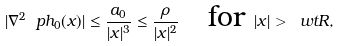<formula> <loc_0><loc_0><loc_500><loc_500>| \nabla ^ { 2 } \ p h _ { 0 } ( x ) | \leq \frac { a _ { 0 } } { | x | ^ { 3 } } \leq \frac { \rho } { | x | ^ { 2 } } \quad \text {for } | x | > { \ w t R } ,</formula> 